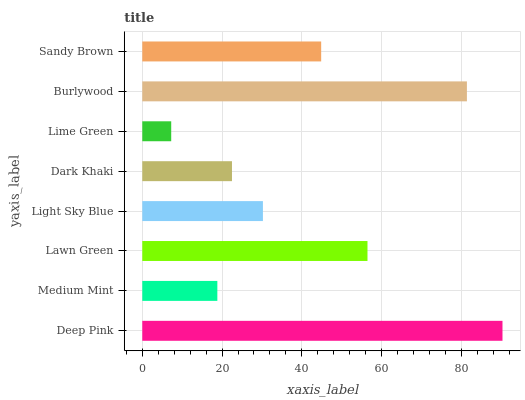Is Lime Green the minimum?
Answer yes or no. Yes. Is Deep Pink the maximum?
Answer yes or no. Yes. Is Medium Mint the minimum?
Answer yes or no. No. Is Medium Mint the maximum?
Answer yes or no. No. Is Deep Pink greater than Medium Mint?
Answer yes or no. Yes. Is Medium Mint less than Deep Pink?
Answer yes or no. Yes. Is Medium Mint greater than Deep Pink?
Answer yes or no. No. Is Deep Pink less than Medium Mint?
Answer yes or no. No. Is Sandy Brown the high median?
Answer yes or no. Yes. Is Light Sky Blue the low median?
Answer yes or no. Yes. Is Burlywood the high median?
Answer yes or no. No. Is Dark Khaki the low median?
Answer yes or no. No. 